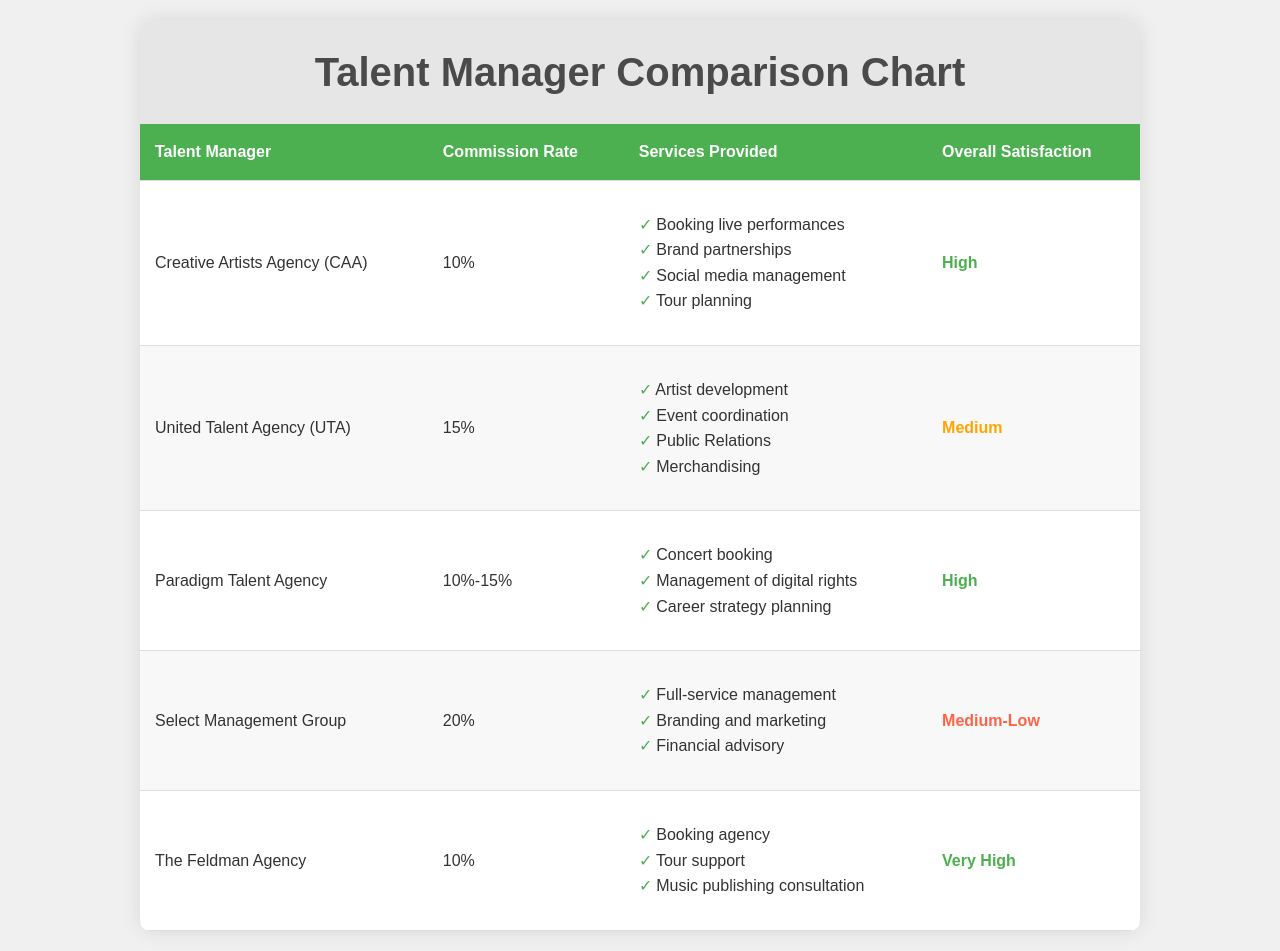What is the commission rate for Creative Artists Agency (CAA)? The commission rate for CAA is specified in the document as 10%.
Answer: 10% Which talent manager has the highest overall satisfaction level? The overall satisfaction levels are provided for each talent manager, and The Feldman Agency has "Very High" satisfaction.
Answer: Very High How many services does United Talent Agency (UTA) provide? The services provided by UTA are listed in a bulleted form, and there are four services mentioned.
Answer: 4 What is the commission rate range for Paradigm Talent Agency? The document states that Paradigm Talent Agency has a commission rate range of 10%-15%.
Answer: 10%-15% What service does Select Management Group NOT provide? The document lists services for Select Management Group, and it does not mention "Music publishing consultation."
Answer: Music publishing consultation Which talent manager charges the highest commission rate? The highest commission rate is charged by Select Management Group, which is 20%.
Answer: 20% What is the satisfaction level of Paradigm Talent Agency? The satisfaction level for Paradigm Talent Agency is labeled as "High" in the document.
Answer: High List one service provided by Creative Artists Agency (CAA). The services provided by CAA include "Booking live performances," among others.
Answer: Booking live performances 